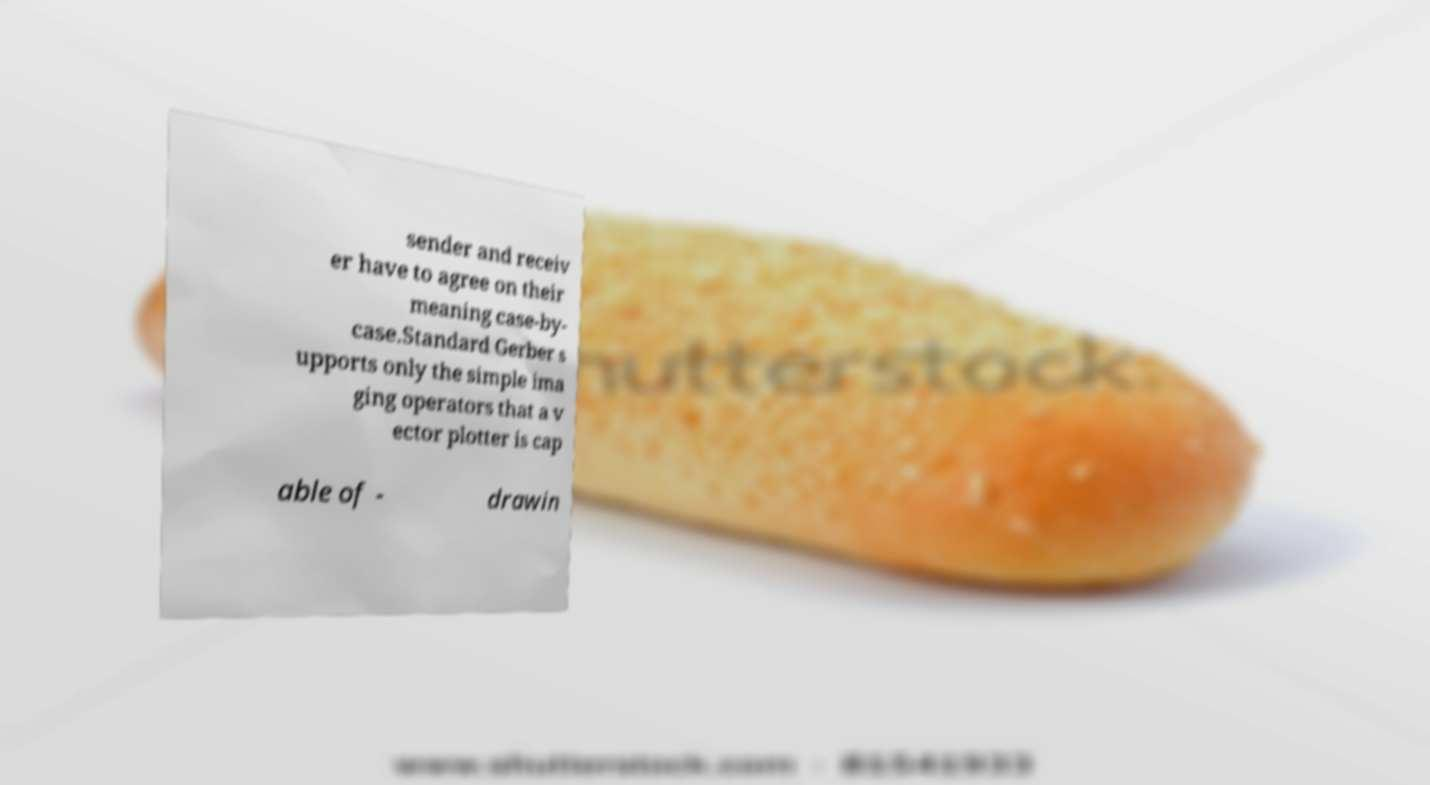What messages or text are displayed in this image? I need them in a readable, typed format. sender and receiv er have to agree on their meaning case-by- case.Standard Gerber s upports only the simple ima ging operators that a v ector plotter is cap able of - drawin 